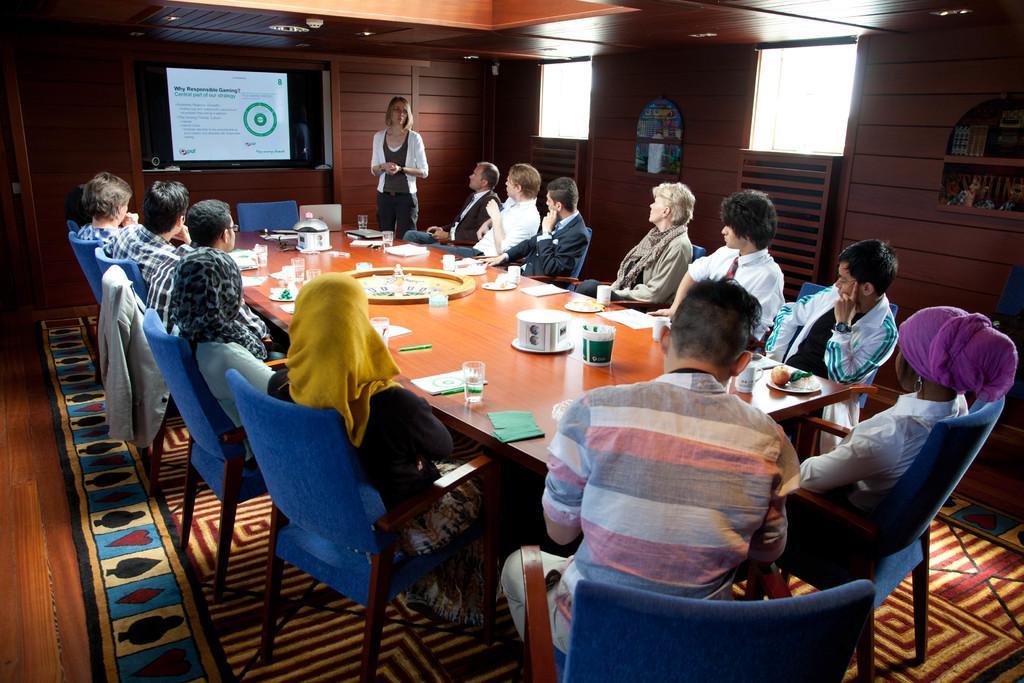How would you summarize this image in a sentence or two? This picture looks like an office meeting. In this we have a lady standing almost at the center of the picture looks like she is in some presentation and the members present on the chairs around the table are listening. On the table we have water glasses, cups, files, papers etc. At the bottom we see large mat present on the floor. 